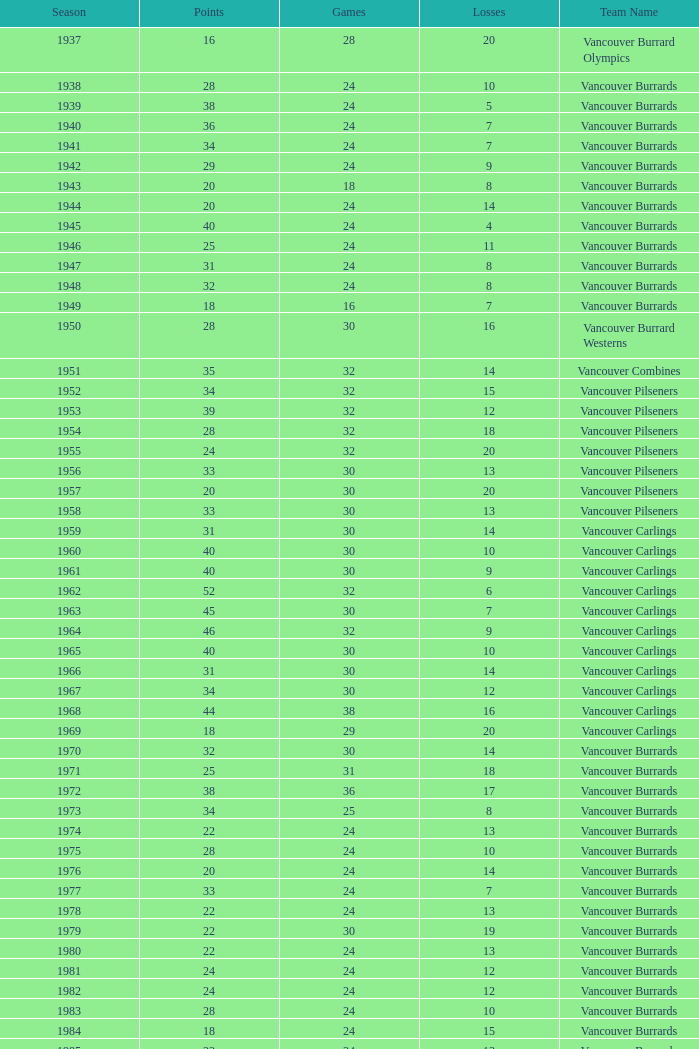What's the total number of points when the vancouver burrards have fewer than 9 losses and more than 24 games? 1.0. 